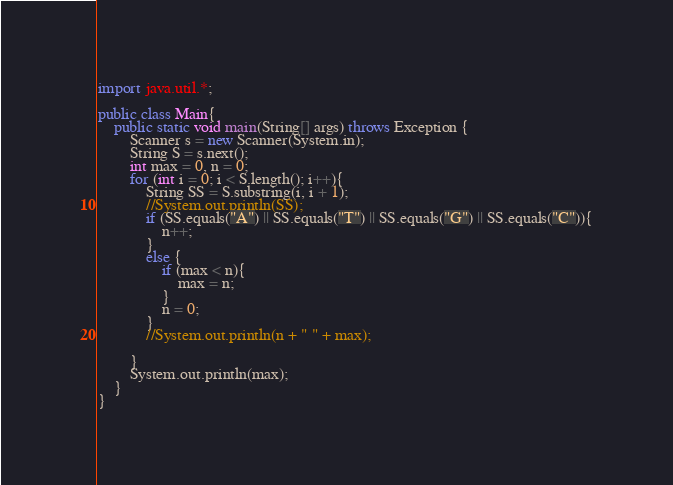<code> <loc_0><loc_0><loc_500><loc_500><_Java_>import java.util.*;

public class Main{
	public static void main(String[] args) throws Exception {
		Scanner s = new Scanner(System.in);
		String S = s.next();
      	int max = 0, n = 0;
      	for (int i = 0; i < S.length(); i++){
          	String SS = S.substring(i, i + 1);
          	//System.out.println(SS);
        	if (SS.equals("A") || SS.equals("T") || SS.equals("G") || SS.equals("C")){
            	n++;
            }
          	else {
            	if (max < n){
            		max = n;
            	}
            	n = 0;
            }
            //System.out.println(n + " " + max);
            
        }
        System.out.println(max);
	}
}</code> 